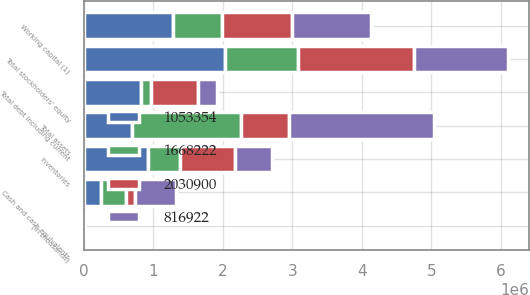Convert chart to OTSL. <chart><loc_0><loc_0><loc_500><loc_500><stacked_bar_chart><ecel><fcel>(In thousands)<fcel>Cash and cash equivalents<fcel>Working capital (1)<fcel>Inventories<fcel>Total assets<fcel>Total debt including current<fcel>Total stockholders' equity<nl><fcel>1.05335e+06<fcel>2016<fcel>250470<fcel>1.27934e+06<fcel>917491<fcel>684126<fcel>817388<fcel>2.0309e+06<nl><fcel>2.0309e+06<fcel>2015<fcel>129852<fcel>1.01995e+06<fcel>783031<fcel>684126<fcel>666070<fcel>1.66822e+06<nl><fcel>816922<fcel>2014<fcel>593175<fcel>1.12777e+06<fcel>536714<fcel>2.09243e+06<fcel>281546<fcel>1.3503e+06<nl><fcel>1.66822e+06<fcel>2013<fcel>347489<fcel>702181<fcel>469006<fcel>1.57637e+06<fcel>151551<fcel>1.05335e+06<nl></chart> 